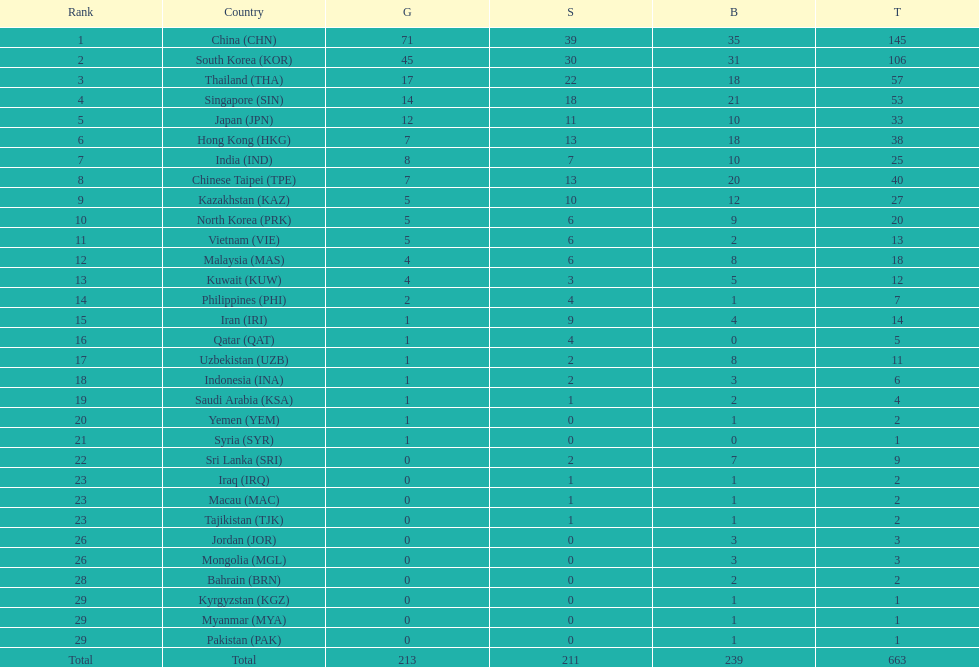How many more gold medals must qatar win before they can earn 12 gold medals? 11. 